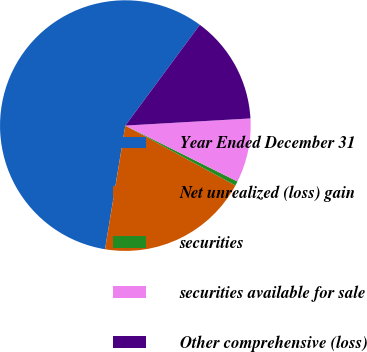Convert chart to OTSL. <chart><loc_0><loc_0><loc_500><loc_500><pie_chart><fcel>Year Ended December 31<fcel>Net unrealized (loss) gain<fcel>securities<fcel>securities available for sale<fcel>Other comprehensive (loss)<nl><fcel>57.54%<fcel>19.66%<fcel>0.57%<fcel>8.27%<fcel>13.96%<nl></chart> 